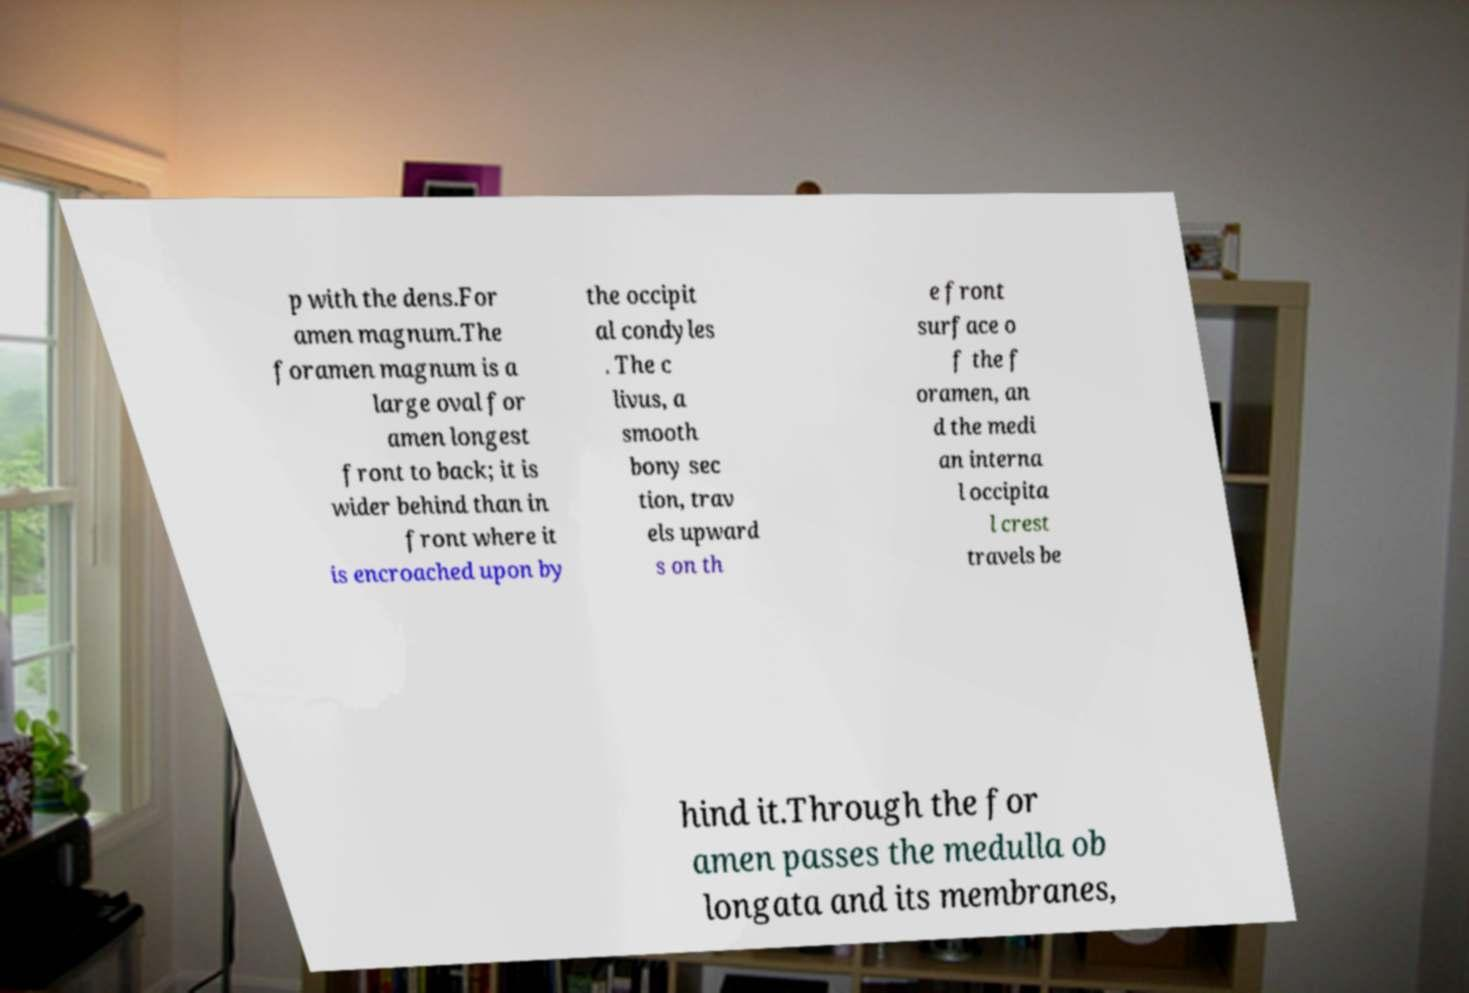There's text embedded in this image that I need extracted. Can you transcribe it verbatim? p with the dens.For amen magnum.The foramen magnum is a large oval for amen longest front to back; it is wider behind than in front where it is encroached upon by the occipit al condyles . The c livus, a smooth bony sec tion, trav els upward s on th e front surface o f the f oramen, an d the medi an interna l occipita l crest travels be hind it.Through the for amen passes the medulla ob longata and its membranes, 